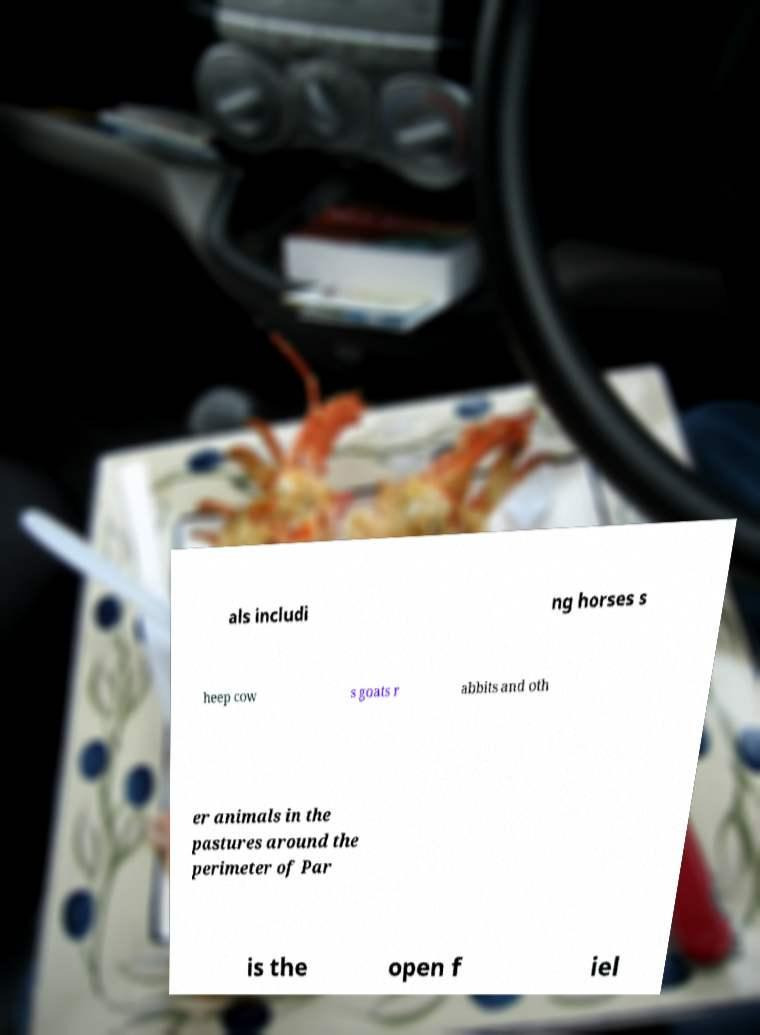I need the written content from this picture converted into text. Can you do that? als includi ng horses s heep cow s goats r abbits and oth er animals in the pastures around the perimeter of Par is the open f iel 